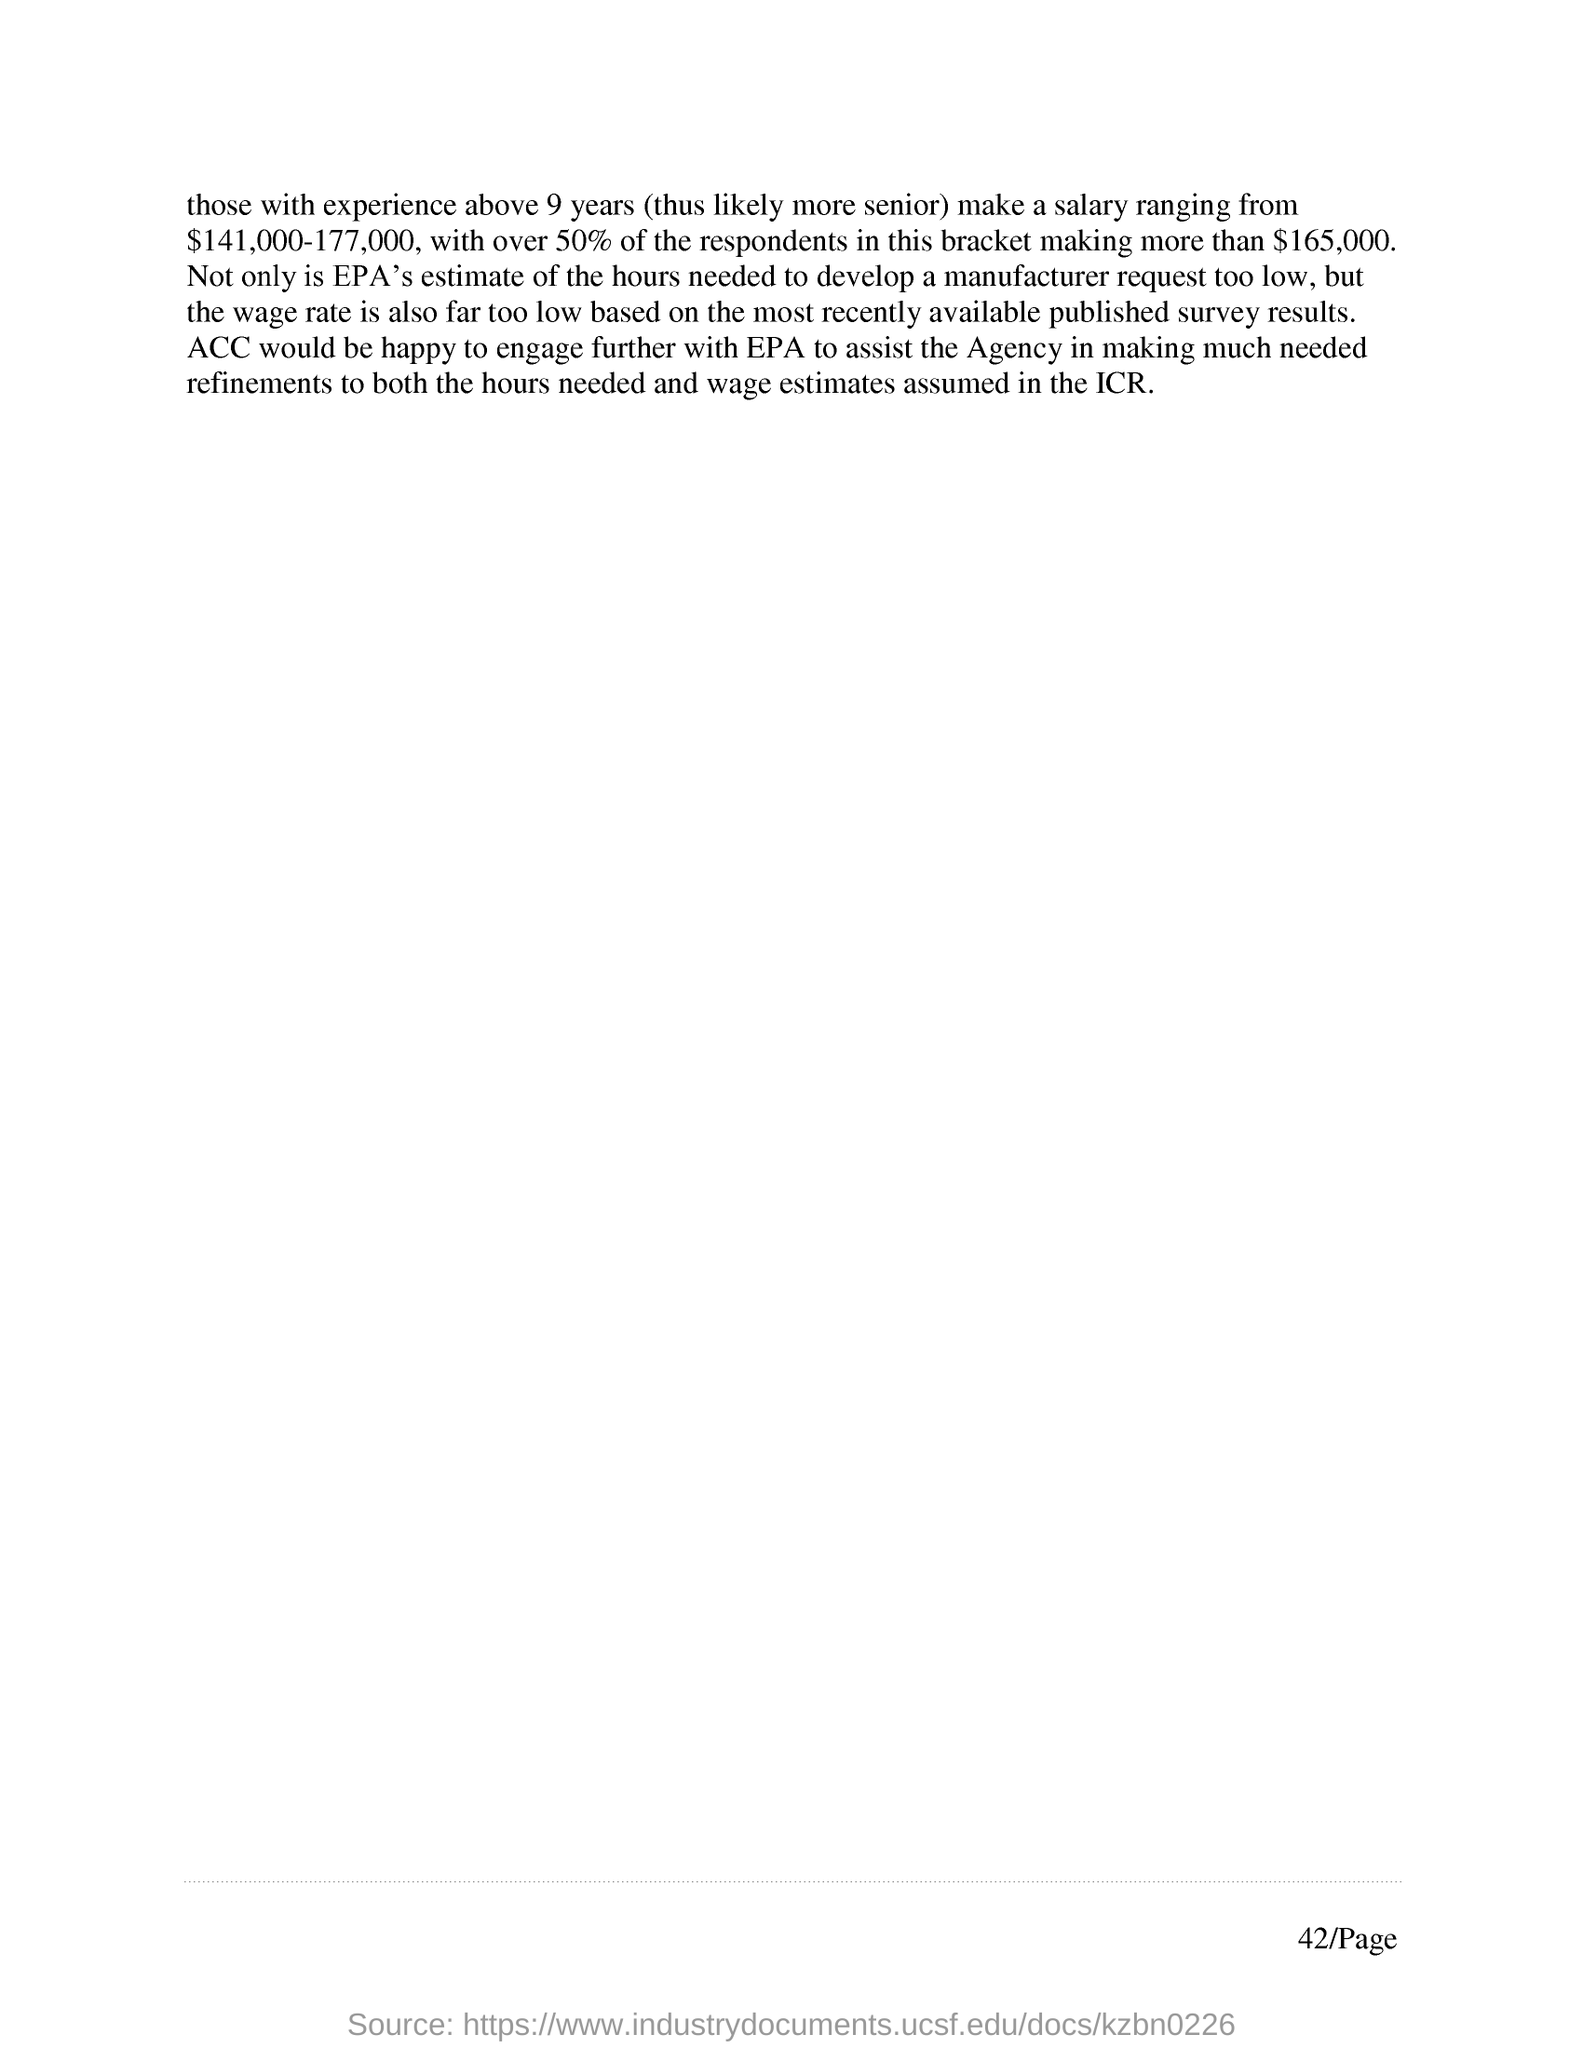How much salary does those with experience above 9 years make?
Keep it short and to the point. $141,000-177,000. How much does over 50% of the respondents in the bracket of $144,000-177,00 salary make?
Provide a short and direct response. $165,000. What is the page number?
Keep it short and to the point. 42. 